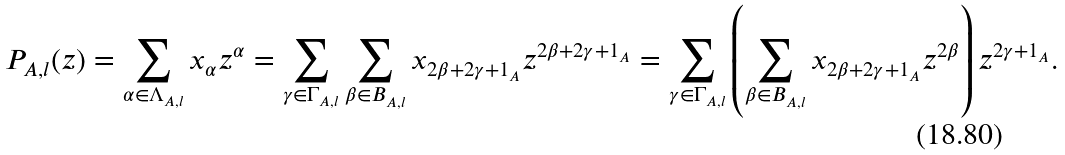Convert formula to latex. <formula><loc_0><loc_0><loc_500><loc_500>P _ { A , l } ( z ) = \sum _ { \alpha \in \Lambda _ { A , l } } x _ { \alpha } z ^ { \alpha } = \sum _ { \gamma \in \Gamma _ { A , l } } \sum _ { \beta \in B _ { A , l } } x _ { 2 \beta + 2 \gamma + 1 _ { A } } z ^ { 2 \beta + 2 \gamma + 1 _ { A } } = \sum _ { \gamma \in \Gamma _ { A , l } } \left ( \sum _ { \beta \in B _ { A , l } } x _ { 2 \beta + 2 \gamma + 1 _ { A } } z ^ { 2 \beta } \right ) z ^ { 2 \gamma + 1 _ { A } } .</formula> 